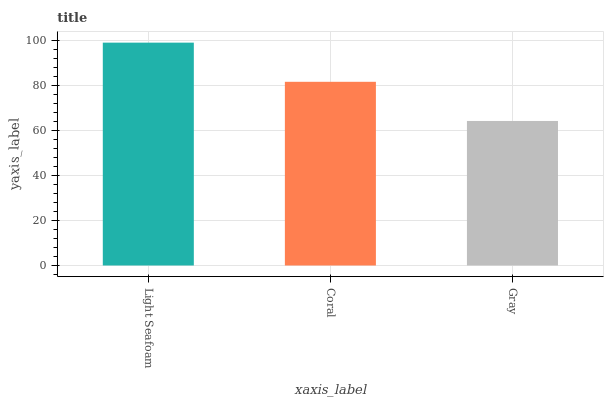Is Gray the minimum?
Answer yes or no. Yes. Is Light Seafoam the maximum?
Answer yes or no. Yes. Is Coral the minimum?
Answer yes or no. No. Is Coral the maximum?
Answer yes or no. No. Is Light Seafoam greater than Coral?
Answer yes or no. Yes. Is Coral less than Light Seafoam?
Answer yes or no. Yes. Is Coral greater than Light Seafoam?
Answer yes or no. No. Is Light Seafoam less than Coral?
Answer yes or no. No. Is Coral the high median?
Answer yes or no. Yes. Is Coral the low median?
Answer yes or no. Yes. Is Gray the high median?
Answer yes or no. No. Is Gray the low median?
Answer yes or no. No. 